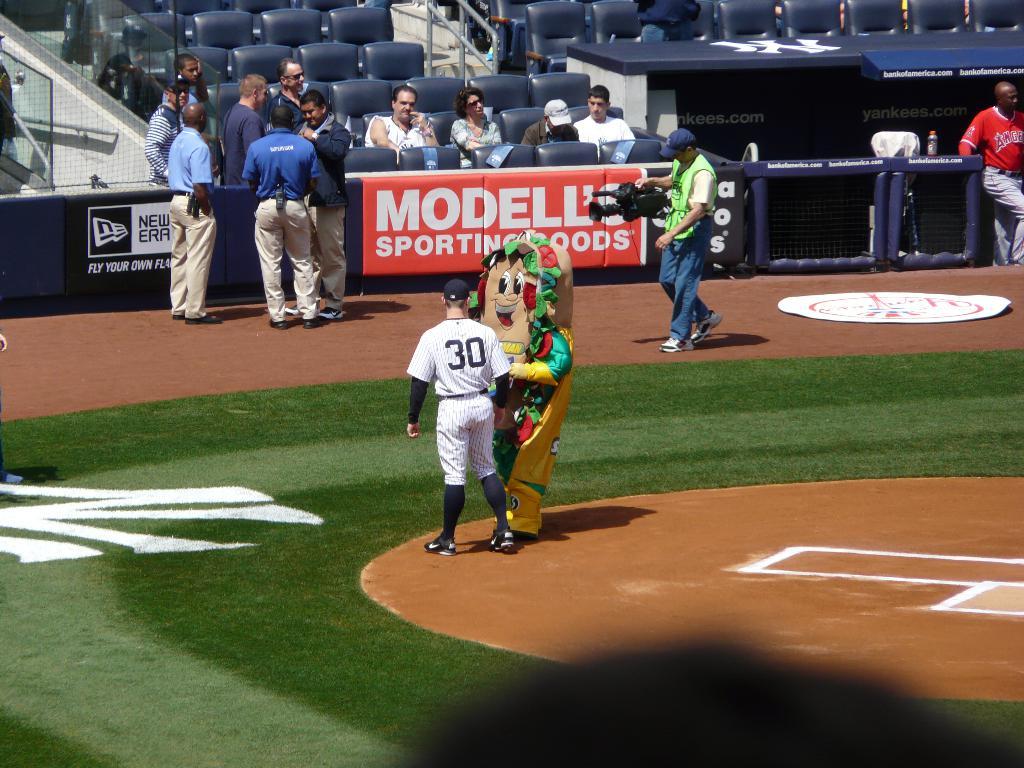What sporting goods store is advertised?
Keep it short and to the point. Modell's. What is the number displayed at the back of his jersey?
Offer a terse response. 30. 